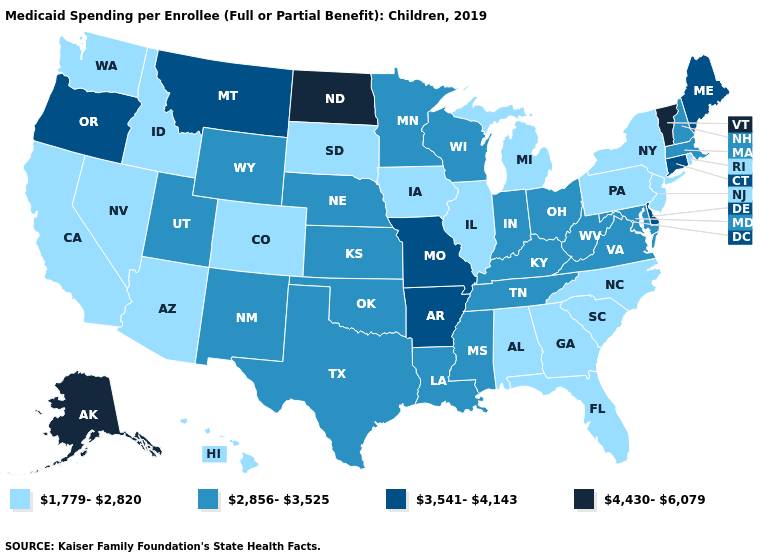Does Minnesota have a lower value than Connecticut?
Give a very brief answer. Yes. Which states have the lowest value in the USA?
Write a very short answer. Alabama, Arizona, California, Colorado, Florida, Georgia, Hawaii, Idaho, Illinois, Iowa, Michigan, Nevada, New Jersey, New York, North Carolina, Pennsylvania, Rhode Island, South Carolina, South Dakota, Washington. Does Alaska have the highest value in the USA?
Be succinct. Yes. What is the value of New Hampshire?
Keep it brief. 2,856-3,525. What is the lowest value in states that border Iowa?
Answer briefly. 1,779-2,820. What is the lowest value in states that border Pennsylvania?
Be succinct. 1,779-2,820. What is the value of Missouri?
Be succinct. 3,541-4,143. Name the states that have a value in the range 1,779-2,820?
Concise answer only. Alabama, Arizona, California, Colorado, Florida, Georgia, Hawaii, Idaho, Illinois, Iowa, Michigan, Nevada, New Jersey, New York, North Carolina, Pennsylvania, Rhode Island, South Carolina, South Dakota, Washington. What is the value of Oklahoma?
Be succinct. 2,856-3,525. Does the map have missing data?
Answer briefly. No. Name the states that have a value in the range 1,779-2,820?
Answer briefly. Alabama, Arizona, California, Colorado, Florida, Georgia, Hawaii, Idaho, Illinois, Iowa, Michigan, Nevada, New Jersey, New York, North Carolina, Pennsylvania, Rhode Island, South Carolina, South Dakota, Washington. Does Nebraska have the lowest value in the MidWest?
Quick response, please. No. Does New Hampshire have the lowest value in the USA?
Give a very brief answer. No. What is the value of Washington?
Concise answer only. 1,779-2,820. Does the first symbol in the legend represent the smallest category?
Answer briefly. Yes. 